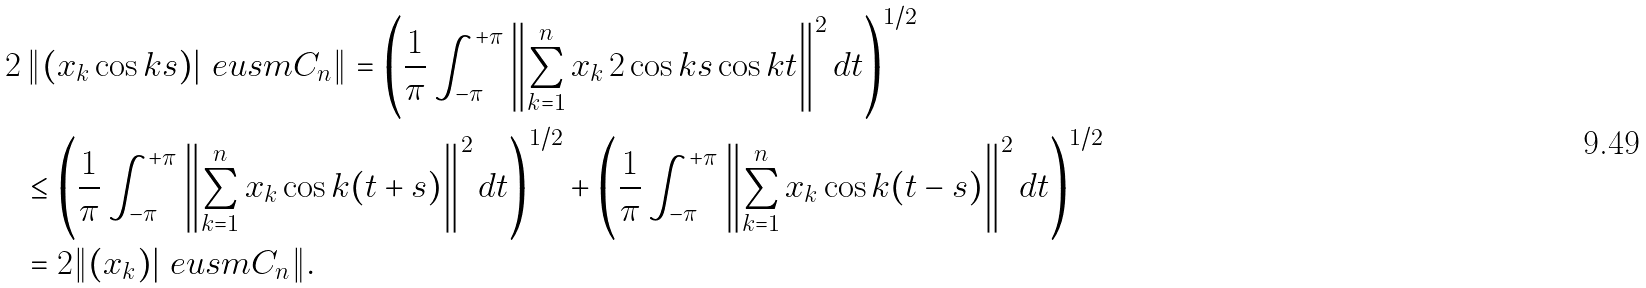Convert formula to latex. <formula><loc_0><loc_0><loc_500><loc_500>2 & \left \| ( x _ { k } \cos k s ) | \ e u s m C _ { n } \right \| = \left ( \frac { 1 } { \pi } \int _ { - \pi } ^ { + \pi } \left \| \sum _ { k = 1 } ^ { n } x _ { k } \, 2 \cos k s \cos k t \right \| ^ { 2 } d t \right ) ^ { 1 / 2 } \\ & \leq \left ( \frac { 1 } { \pi } \int _ { - \pi } ^ { + \pi } \left \| \sum _ { k = 1 } ^ { n } x _ { k } \cos k ( t + s ) \right \| ^ { 2 } d t \right ) ^ { 1 / 2 } + \left ( \frac { 1 } { \pi } \int _ { - \pi } ^ { + \pi } \left \| \sum _ { k = 1 } ^ { n } x _ { k } \cos k ( t - s ) \right \| ^ { 2 } d t \right ) ^ { 1 / 2 } \\ & = 2 \| ( x _ { k } ) | \ e u s m C _ { n } \| .</formula> 